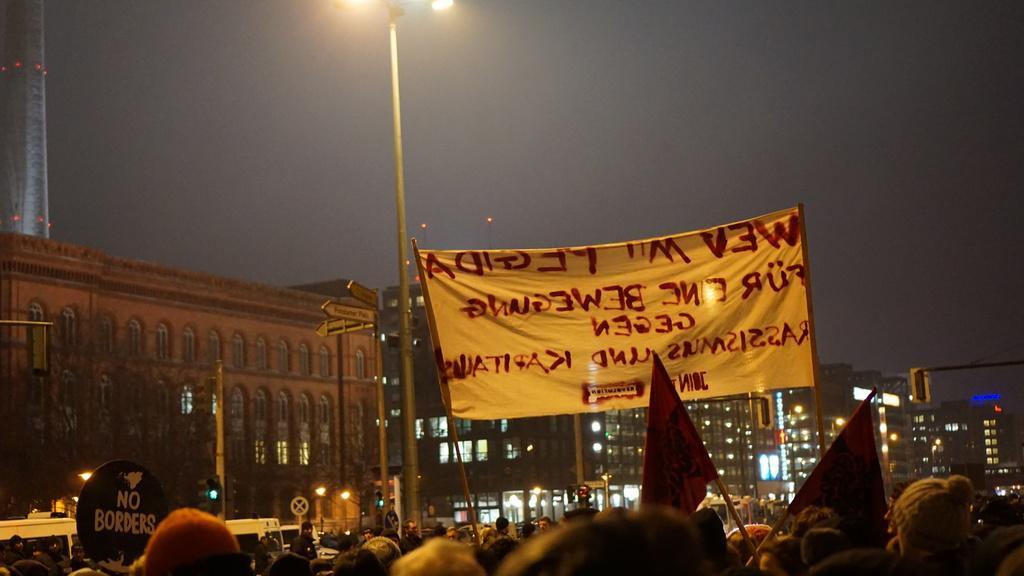Could you give a brief overview of what you see in this image? In the image I can see group of people are standing on the ground. In the background I can see banners, buildings, pole lights, flags, the sky and some other objects. 